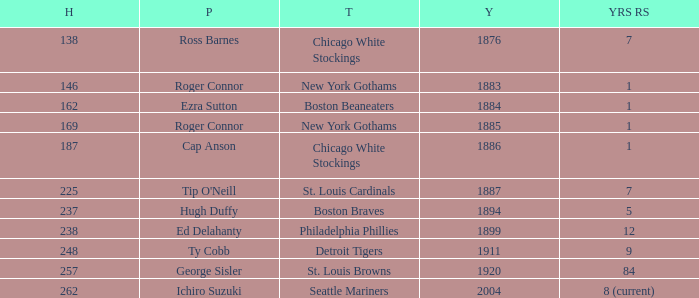Name the player with 238 hits and years after 1885 Ed Delahanty. 